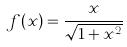<formula> <loc_0><loc_0><loc_500><loc_500>f ( x ) = \frac { x } { \sqrt { 1 + x ^ { 2 } } }</formula> 